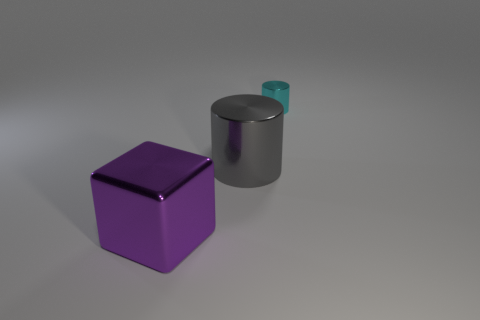Add 2 metal cubes. How many objects exist? 5 Subtract all cylinders. How many objects are left? 1 Add 1 metal cylinders. How many metal cylinders are left? 3 Add 3 small metal objects. How many small metal objects exist? 4 Subtract 1 cyan cylinders. How many objects are left? 2 Subtract all small cyan metallic objects. Subtract all small cyan objects. How many objects are left? 1 